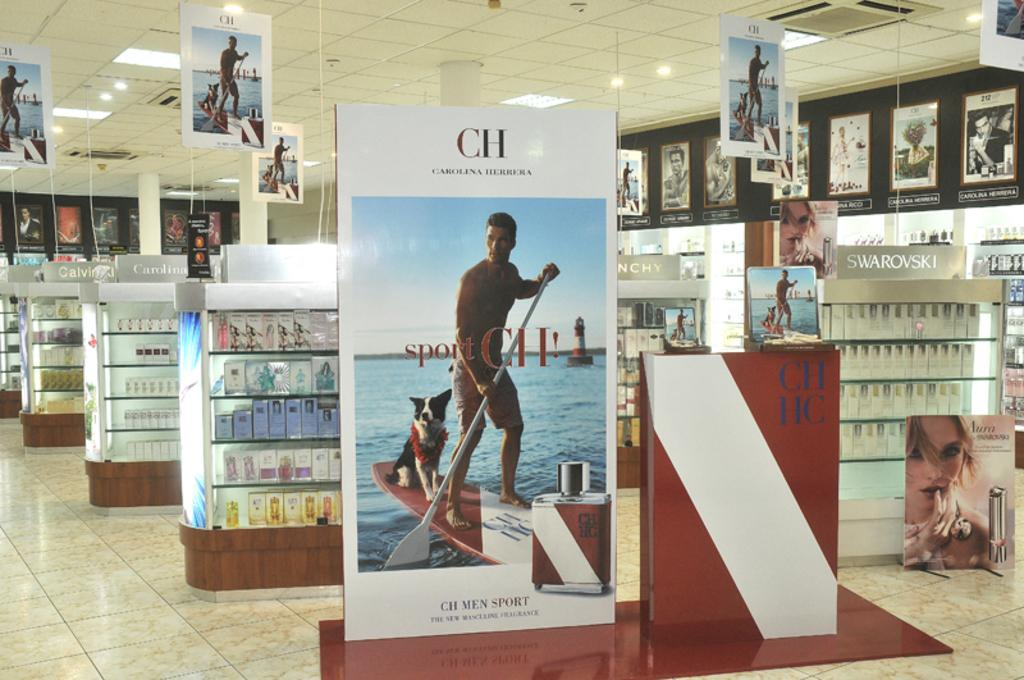<image>
Give a short and clear explanation of the subsequent image. Various store shelves with different items on them in a store and oen is labeled, Swarovski. 